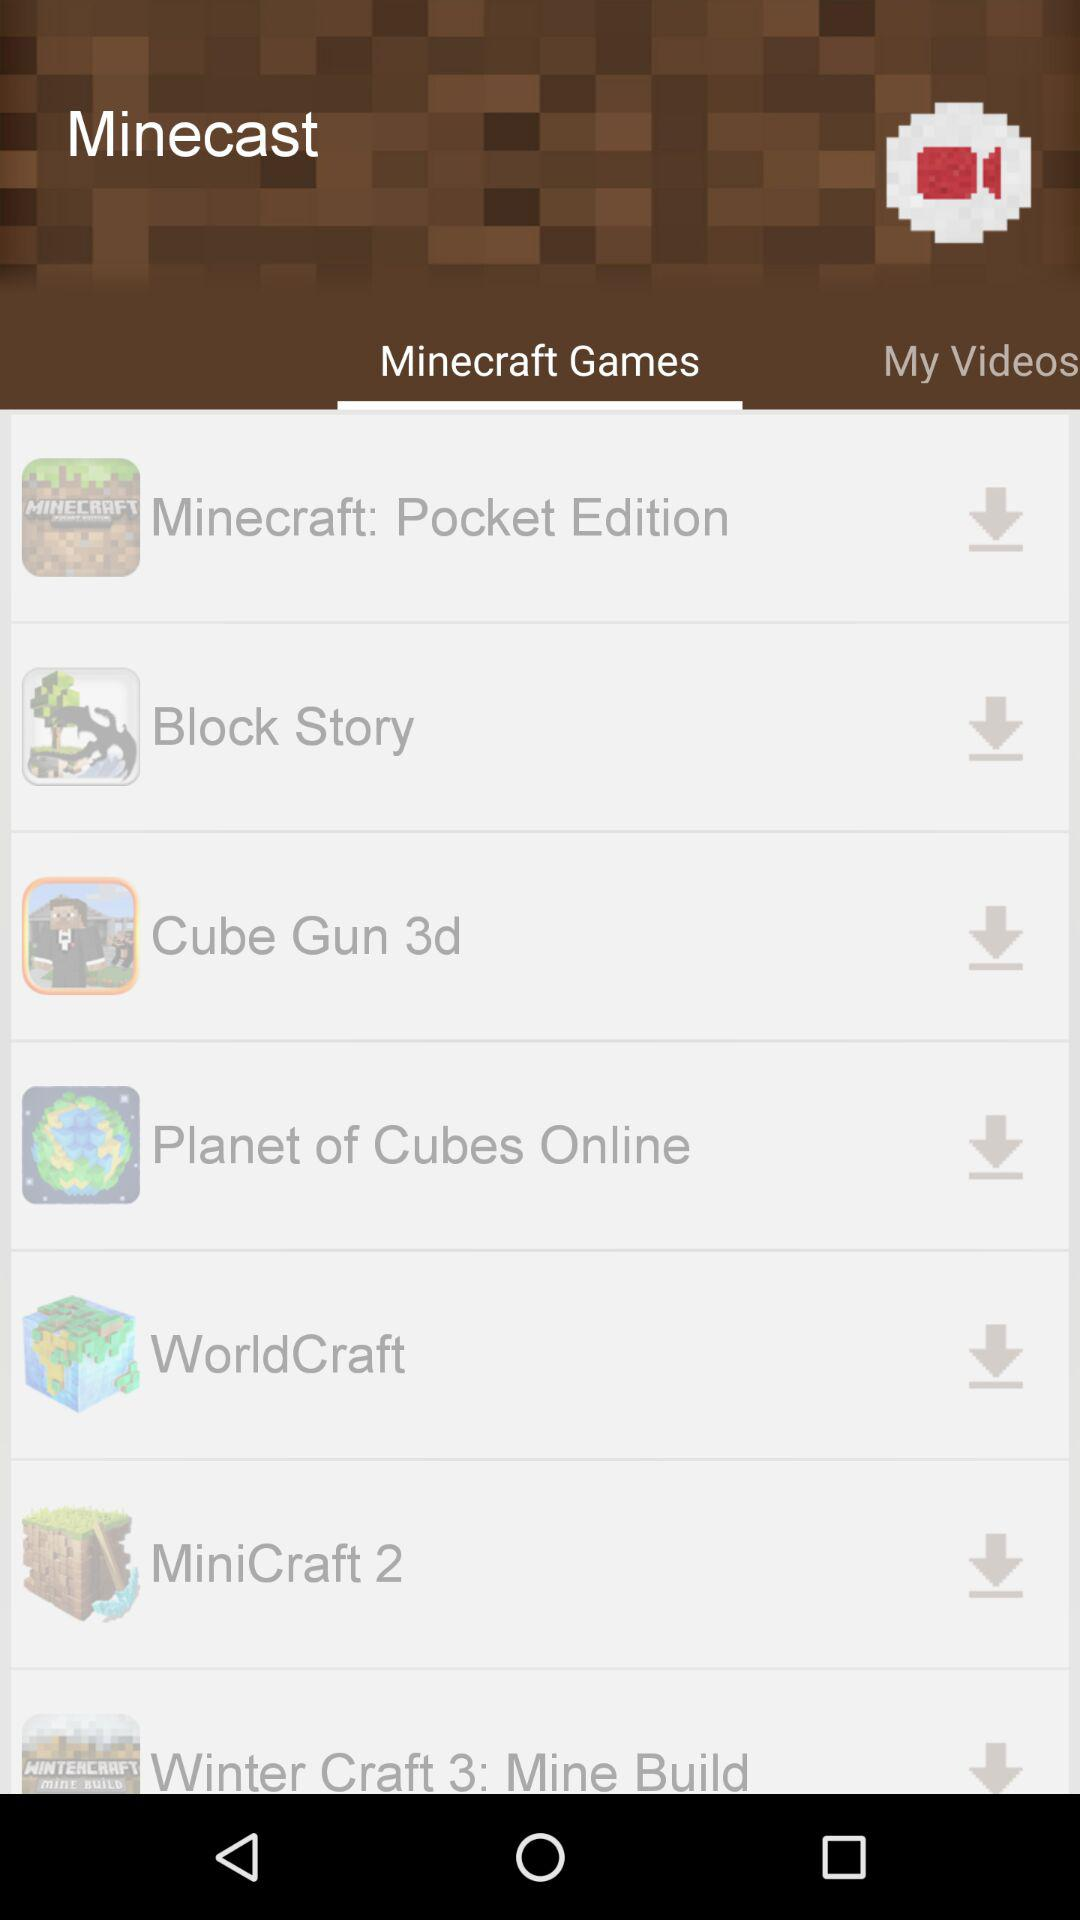What are the games available? The games available are : "Minecraft: Pocket Edition", "Block Story", "Cube Gun 3d", "Planet of Cubes Online", "WorldCraft", "MiniCraft 2", and "Winter Craft 3: Mine Build". 